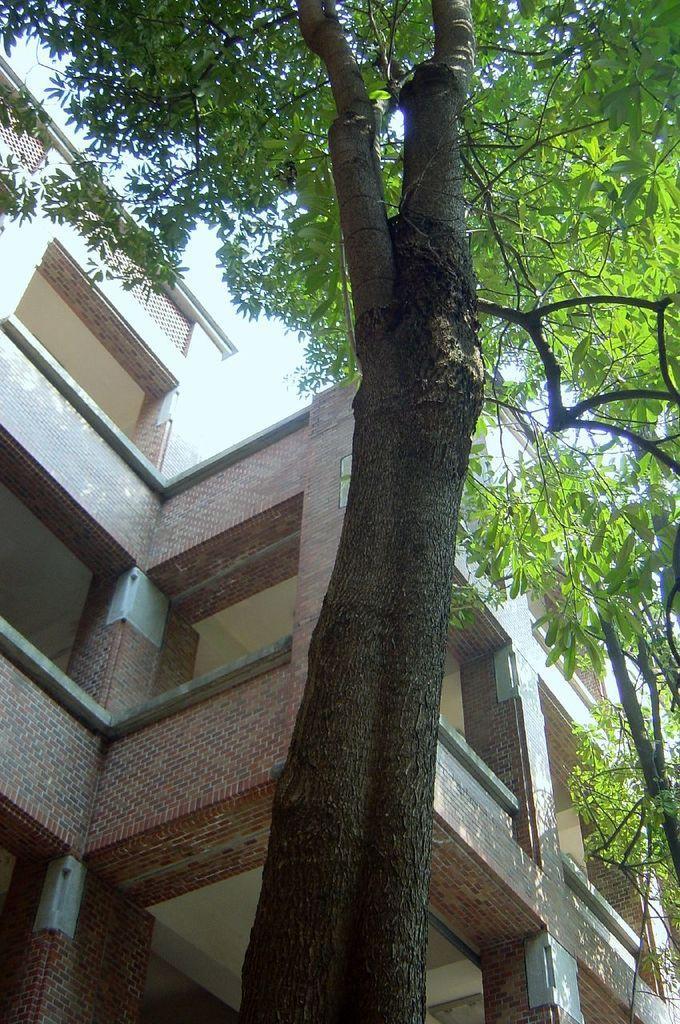Can you describe this image briefly? In this image in the foreground there are trees, and in the background there is a building and sky. 